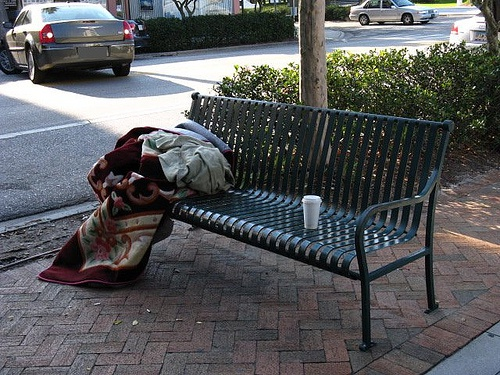Describe the objects in this image and their specific colors. I can see bench in gray, black, blue, and darkblue tones, car in gray, black, white, and darkgray tones, car in gray, darkgray, black, and white tones, car in gray, white, and darkgray tones, and cup in gray, darkgray, and black tones in this image. 